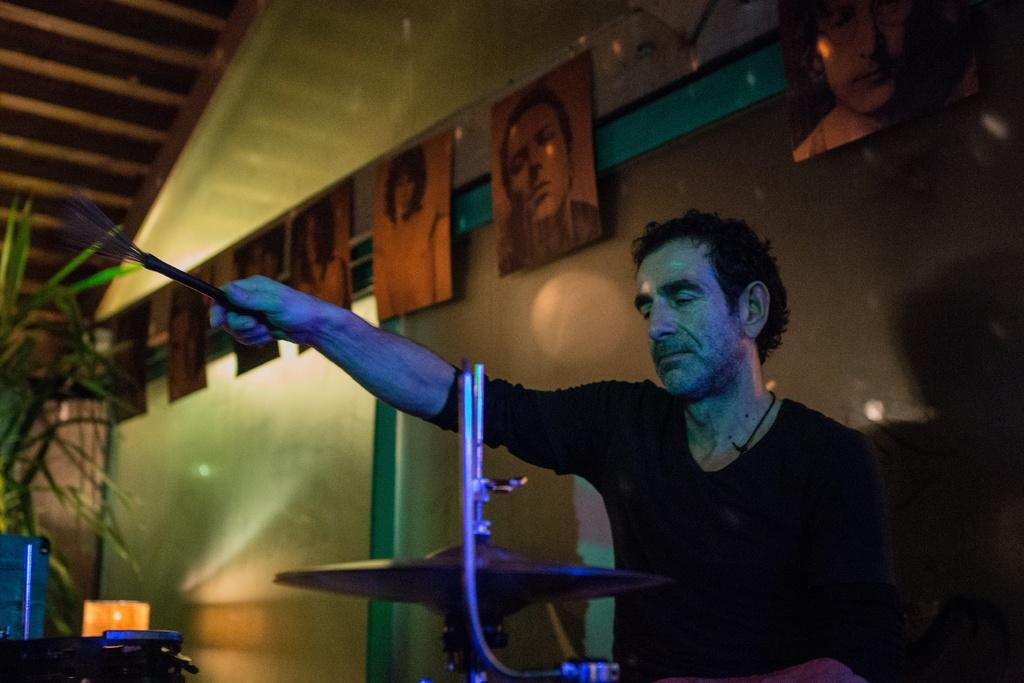What is the man in the image doing? The man is sitting in the image. What is the man holding in the image? The man is holding an object, which appears to be a hi-hat instrument. What can be seen on the wall in the image? There are frames attached to the wall in the image. What type of plant is present in the image? There is a houseplant in the image. What type of wrench can be seen being used on the wire in the image? There is no wrench or wire present in the image. What type of park is visible in the background of the image? There is no park visible in the image; it is an indoor setting with a man sitting, holding a hi-hat instrument, and frames on the wall. 